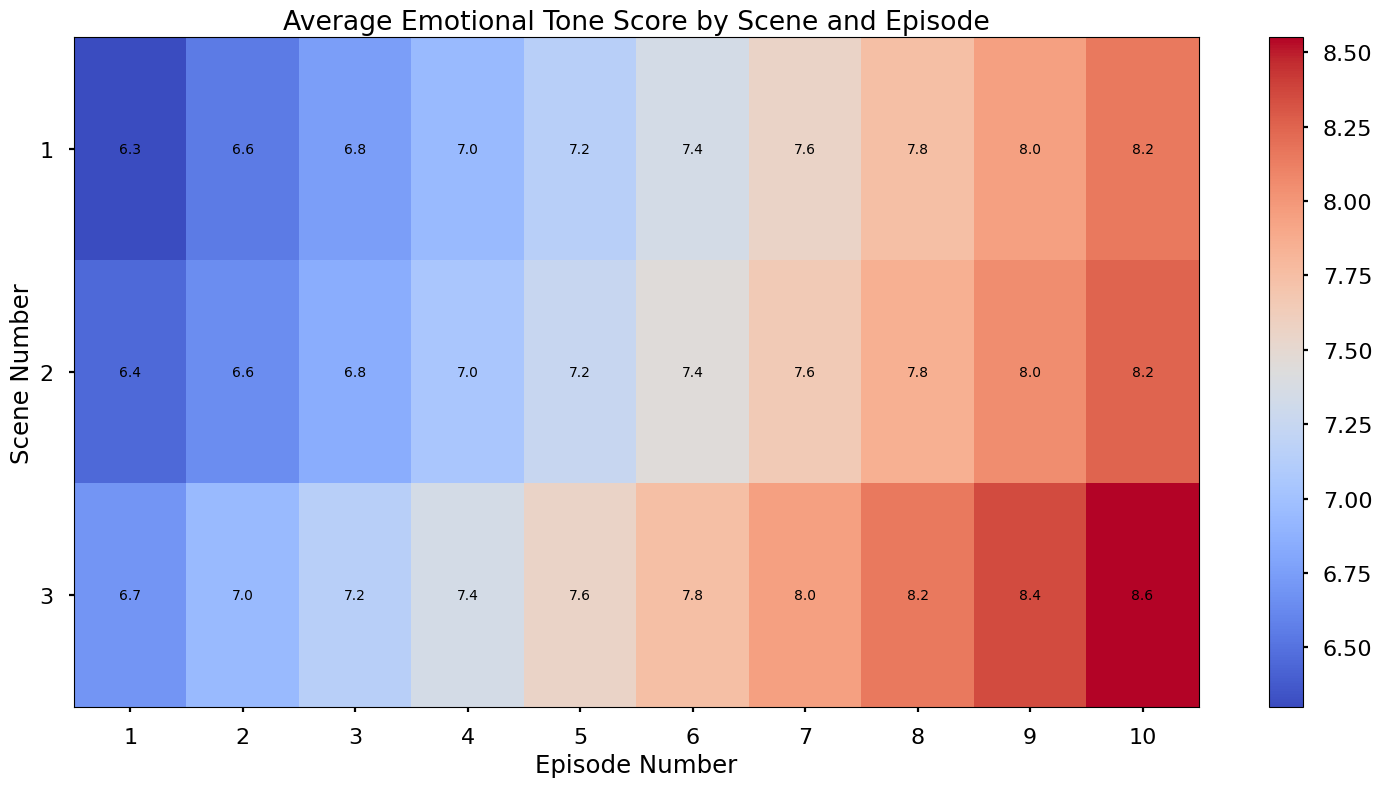What is the average emotional tone score across scenes in Episode 5? To find the average emotional tone score for Episode 5, locate the column for Episode 5 in the heatmap. Add the values for each scene (1, 2, 3) and divide by the number of scenes. (8.0 + 7.6 + 8.5 + 6.3 + 6.9 + 6.6) / 6 = 44.9 / 6 = 7.48
Answer: 7.5 Which episode has the highest average emotional tone score in Scene 3? Compare the values for Scene 3 across all episodes in the heatmap. Find the episode with the highest value. 1 (7.5), 2 (7.9), 3 (8.1), 4 (8.3), 5 (8.5), 6 (8.7), 7 (8.9), 8 (9.1), 9 (9.3), 10 (9.5). Episode 10 has the highest value of 9.5
Answer: Episode 10 Does Bernard’s emotional tone score increase or decrease from Episode 1 to Episode 10 in Scene 1? Compare Bernard’s tone score in Scene 1 for Episodes 1 and 10. Scene 1, Episode 1: 5.4, Scene 1, Episode 10: 7.3. The score increases.
Answer: Increase Are the emotional tone scores visually more uniform across scenes in earlier episodes or later episodes? Observe the heatmap color gradients. Uniformity is indicated by similar colors. Early episodes show more variance in colors, while later episodes show more uniformity, especially Episodes 8-10.
Answer: Later episodes In which scene and episode combination is the lowest average emotional tone score recorded? Identify the darkest area in the heatmap, which represents the lowest score. Scene 1, Episode 1, with a score of 5.4, is the darkest area.
Answer: Scene 1, Episode 1 Do the emotional tone scores for Dolores increase consistently across episodes? Track Dolores' scores across episodes for any scene. For Scene 1: 7.2, 7.4, 7.6, 7.8, 8.0, 8.2, 8.4, 8.6, 8.8, 9.0, which show a consistent increase.
Answer: Yes Is there any episode where the emotional tone score for Scene 2 is higher than Scene 3 on average? Compare Scene 2 and Scene 3 scores for each episode. Average all values of Scene 2: 6.8 to 8.6 (average = 8.2) and Scene 3: 7.2 to 9.5 (average = 8.4). No Scene 2 score exceeds Scene 3.
Answer: No What’s the difference in emotional tone score between Scene 3 in Episode 3 and Scene 1 in Episode 6? Locate and subtract the scores: Scene 3, Episode 3 (8.1) - Scene 1, Episode 6 (8.2) = 8.1 - 8.2 = -0.1
Answer: -0.1 Which scene number shows the greatest increase in emotional tone score from Episode 1 to Episode 10? Calculate the increase for each scene number: Scene 1: 9.0 - 7.2 = 1.8, Scene 2: 8.6 - 6.8 = 1.8, Scene 3: 9.5 - 7.5 = 2.0. Scene 3 shows the greatest increase of 2.0.
Answer: Scene 3 